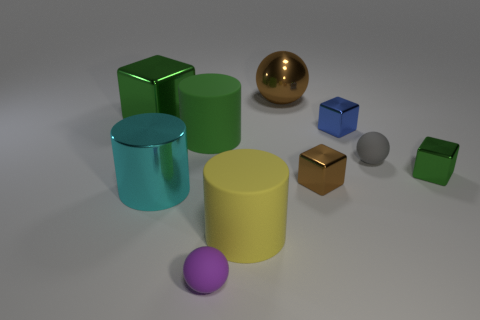Are any tiny red rubber cubes visible? no 